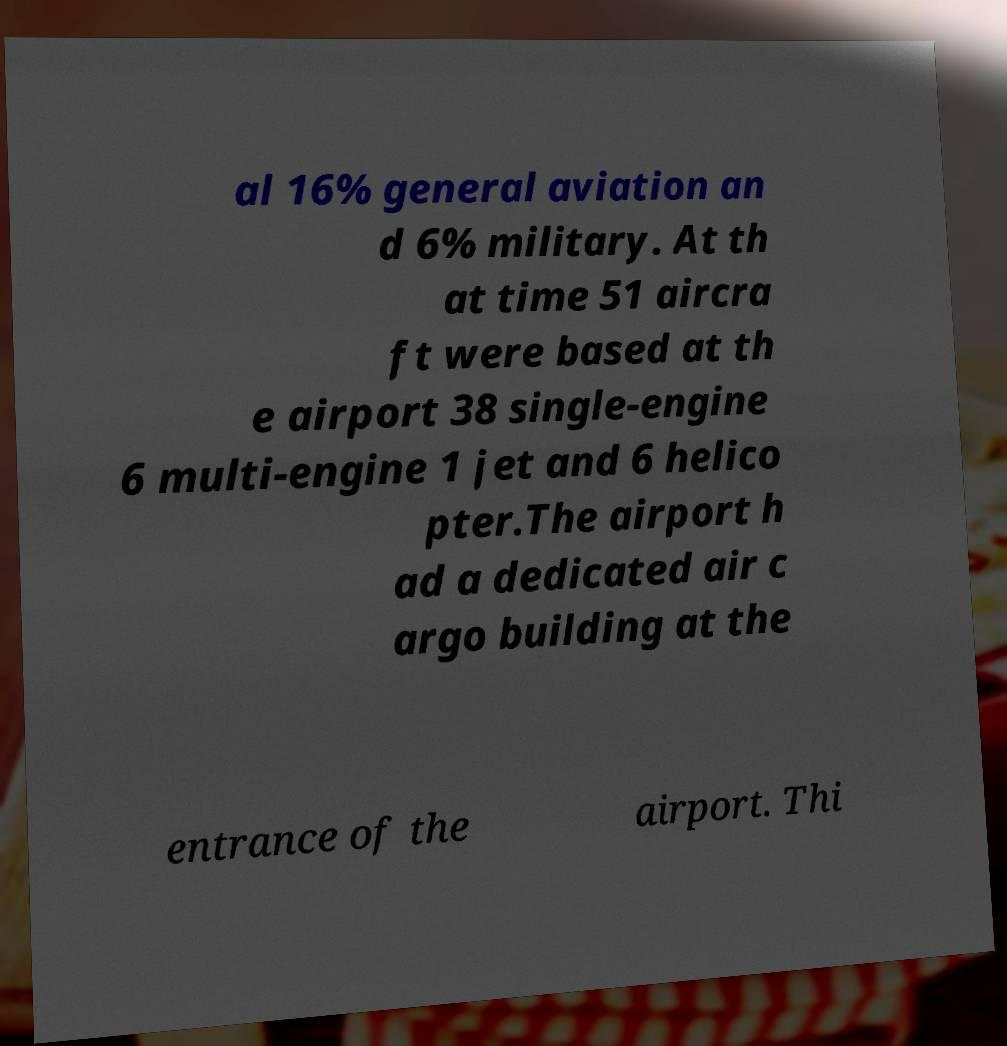Can you read and provide the text displayed in the image?This photo seems to have some interesting text. Can you extract and type it out for me? al 16% general aviation an d 6% military. At th at time 51 aircra ft were based at th e airport 38 single-engine 6 multi-engine 1 jet and 6 helico pter.The airport h ad a dedicated air c argo building at the entrance of the airport. Thi 